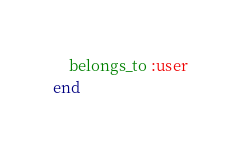Convert code to text. <code><loc_0><loc_0><loc_500><loc_500><_Ruby_>    belongs_to :user
end
</code> 